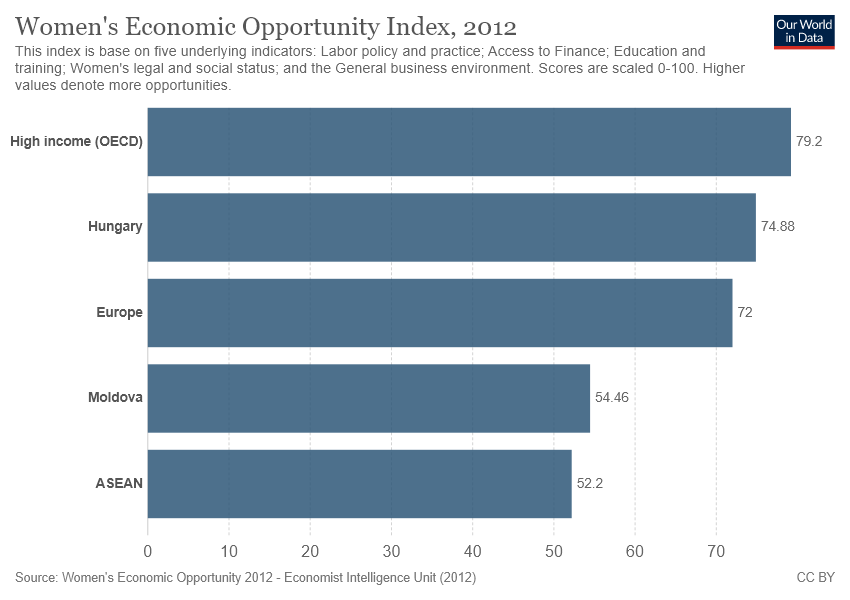Mention a couple of crucial points in this snapshot. After taking the highest value and deducting the median value from it, the result is 7.2. The minimum value of the bar is 52.2. 